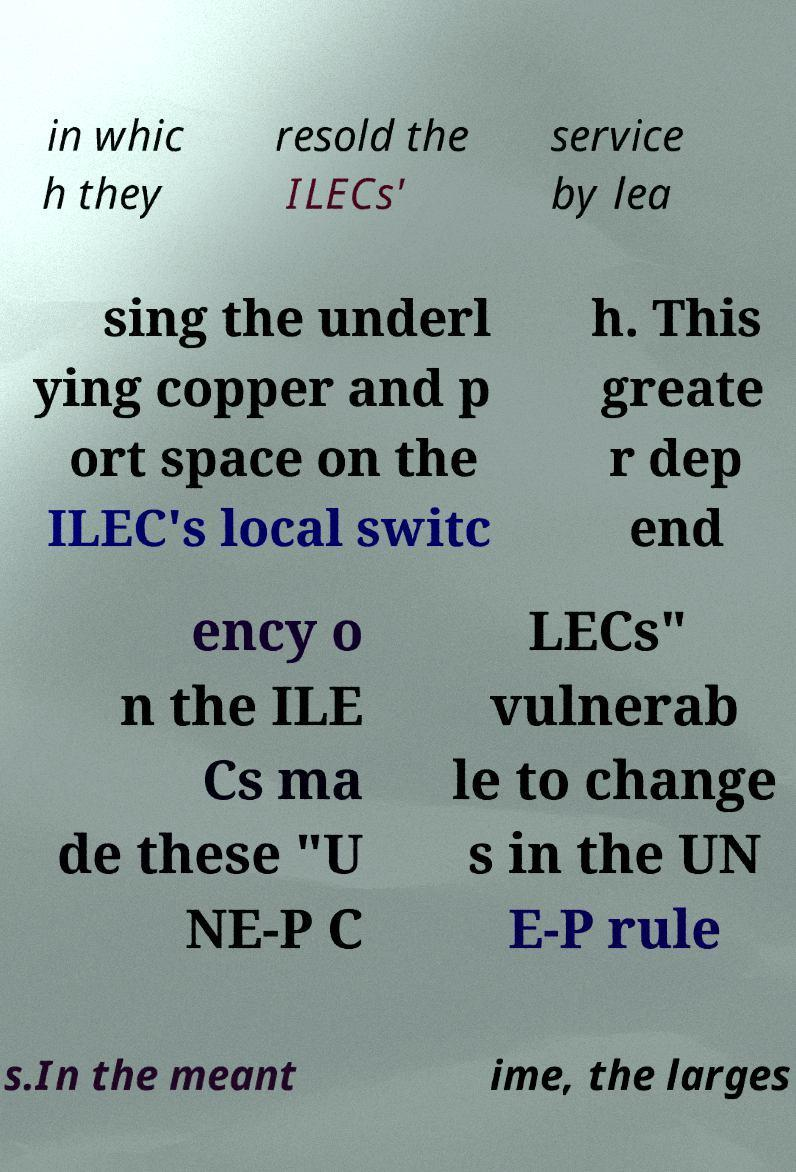Can you accurately transcribe the text from the provided image for me? in whic h they resold the ILECs' service by lea sing the underl ying copper and p ort space on the ILEC's local switc h. This greate r dep end ency o n the ILE Cs ma de these "U NE-P C LECs" vulnerab le to change s in the UN E-P rule s.In the meant ime, the larges 